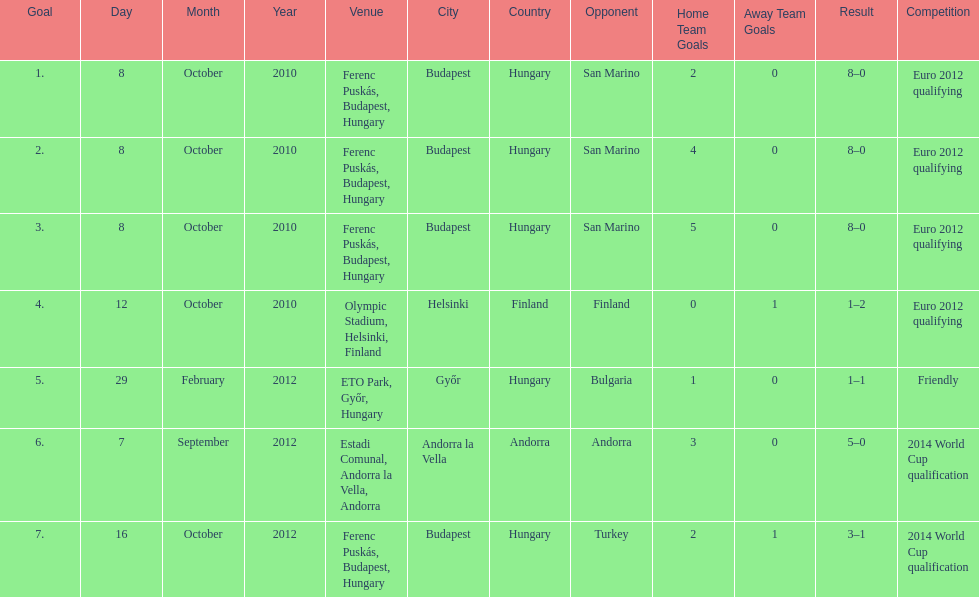In what year was szalai's first international goal? 2010. 